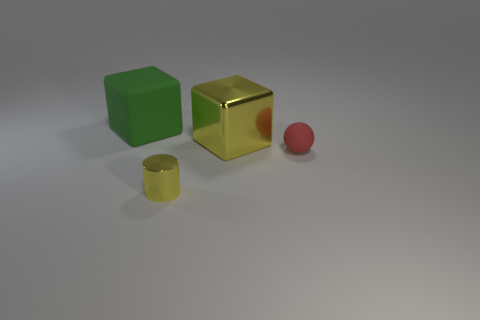Add 4 small yellow shiny cylinders. How many objects exist? 8 Subtract all balls. How many objects are left? 3 Subtract 1 green cubes. How many objects are left? 3 Subtract all large matte objects. Subtract all big things. How many objects are left? 1 Add 1 large metallic things. How many large metallic things are left? 2 Add 4 large metal cubes. How many large metal cubes exist? 5 